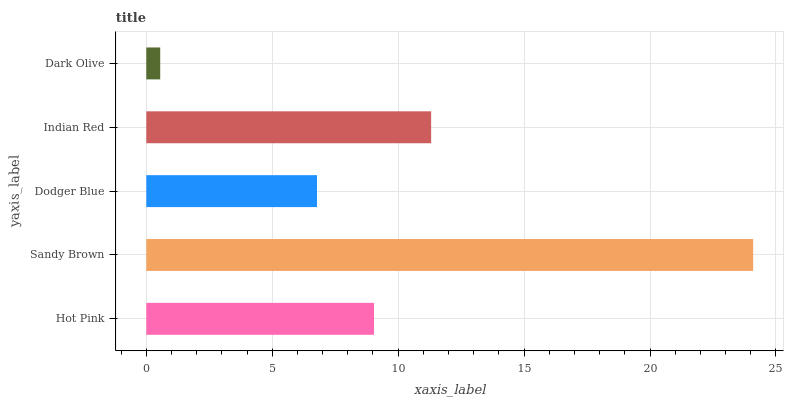Is Dark Olive the minimum?
Answer yes or no. Yes. Is Sandy Brown the maximum?
Answer yes or no. Yes. Is Dodger Blue the minimum?
Answer yes or no. No. Is Dodger Blue the maximum?
Answer yes or no. No. Is Sandy Brown greater than Dodger Blue?
Answer yes or no. Yes. Is Dodger Blue less than Sandy Brown?
Answer yes or no. Yes. Is Dodger Blue greater than Sandy Brown?
Answer yes or no. No. Is Sandy Brown less than Dodger Blue?
Answer yes or no. No. Is Hot Pink the high median?
Answer yes or no. Yes. Is Hot Pink the low median?
Answer yes or no. Yes. Is Sandy Brown the high median?
Answer yes or no. No. Is Dark Olive the low median?
Answer yes or no. No. 